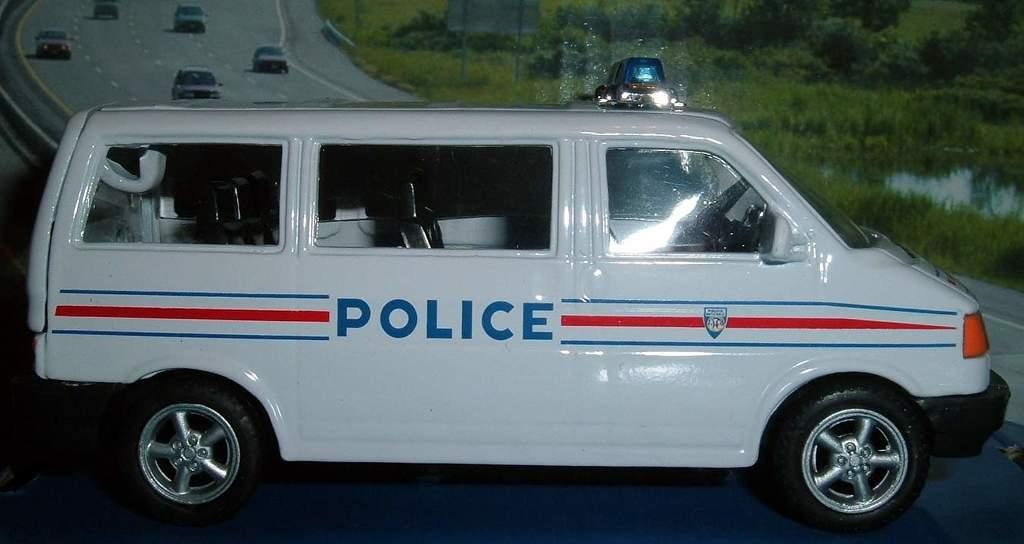What type of vehicle is in the middle of the image? There is a white miniature police van in the image. Where is the van located in relation to the image? The van is in the middle of the image. What can be seen in the background of the image? There is a poster in the background of the image. What is depicted on the poster? The poster depicts moving cars. Can you see a frog hopping on the miniature police van in the image? No, there is no frog present on the miniature police van in the image. What type of facial expression does the poster have? The poster does not have a face or any facial expression, as it depicts moving cars. 